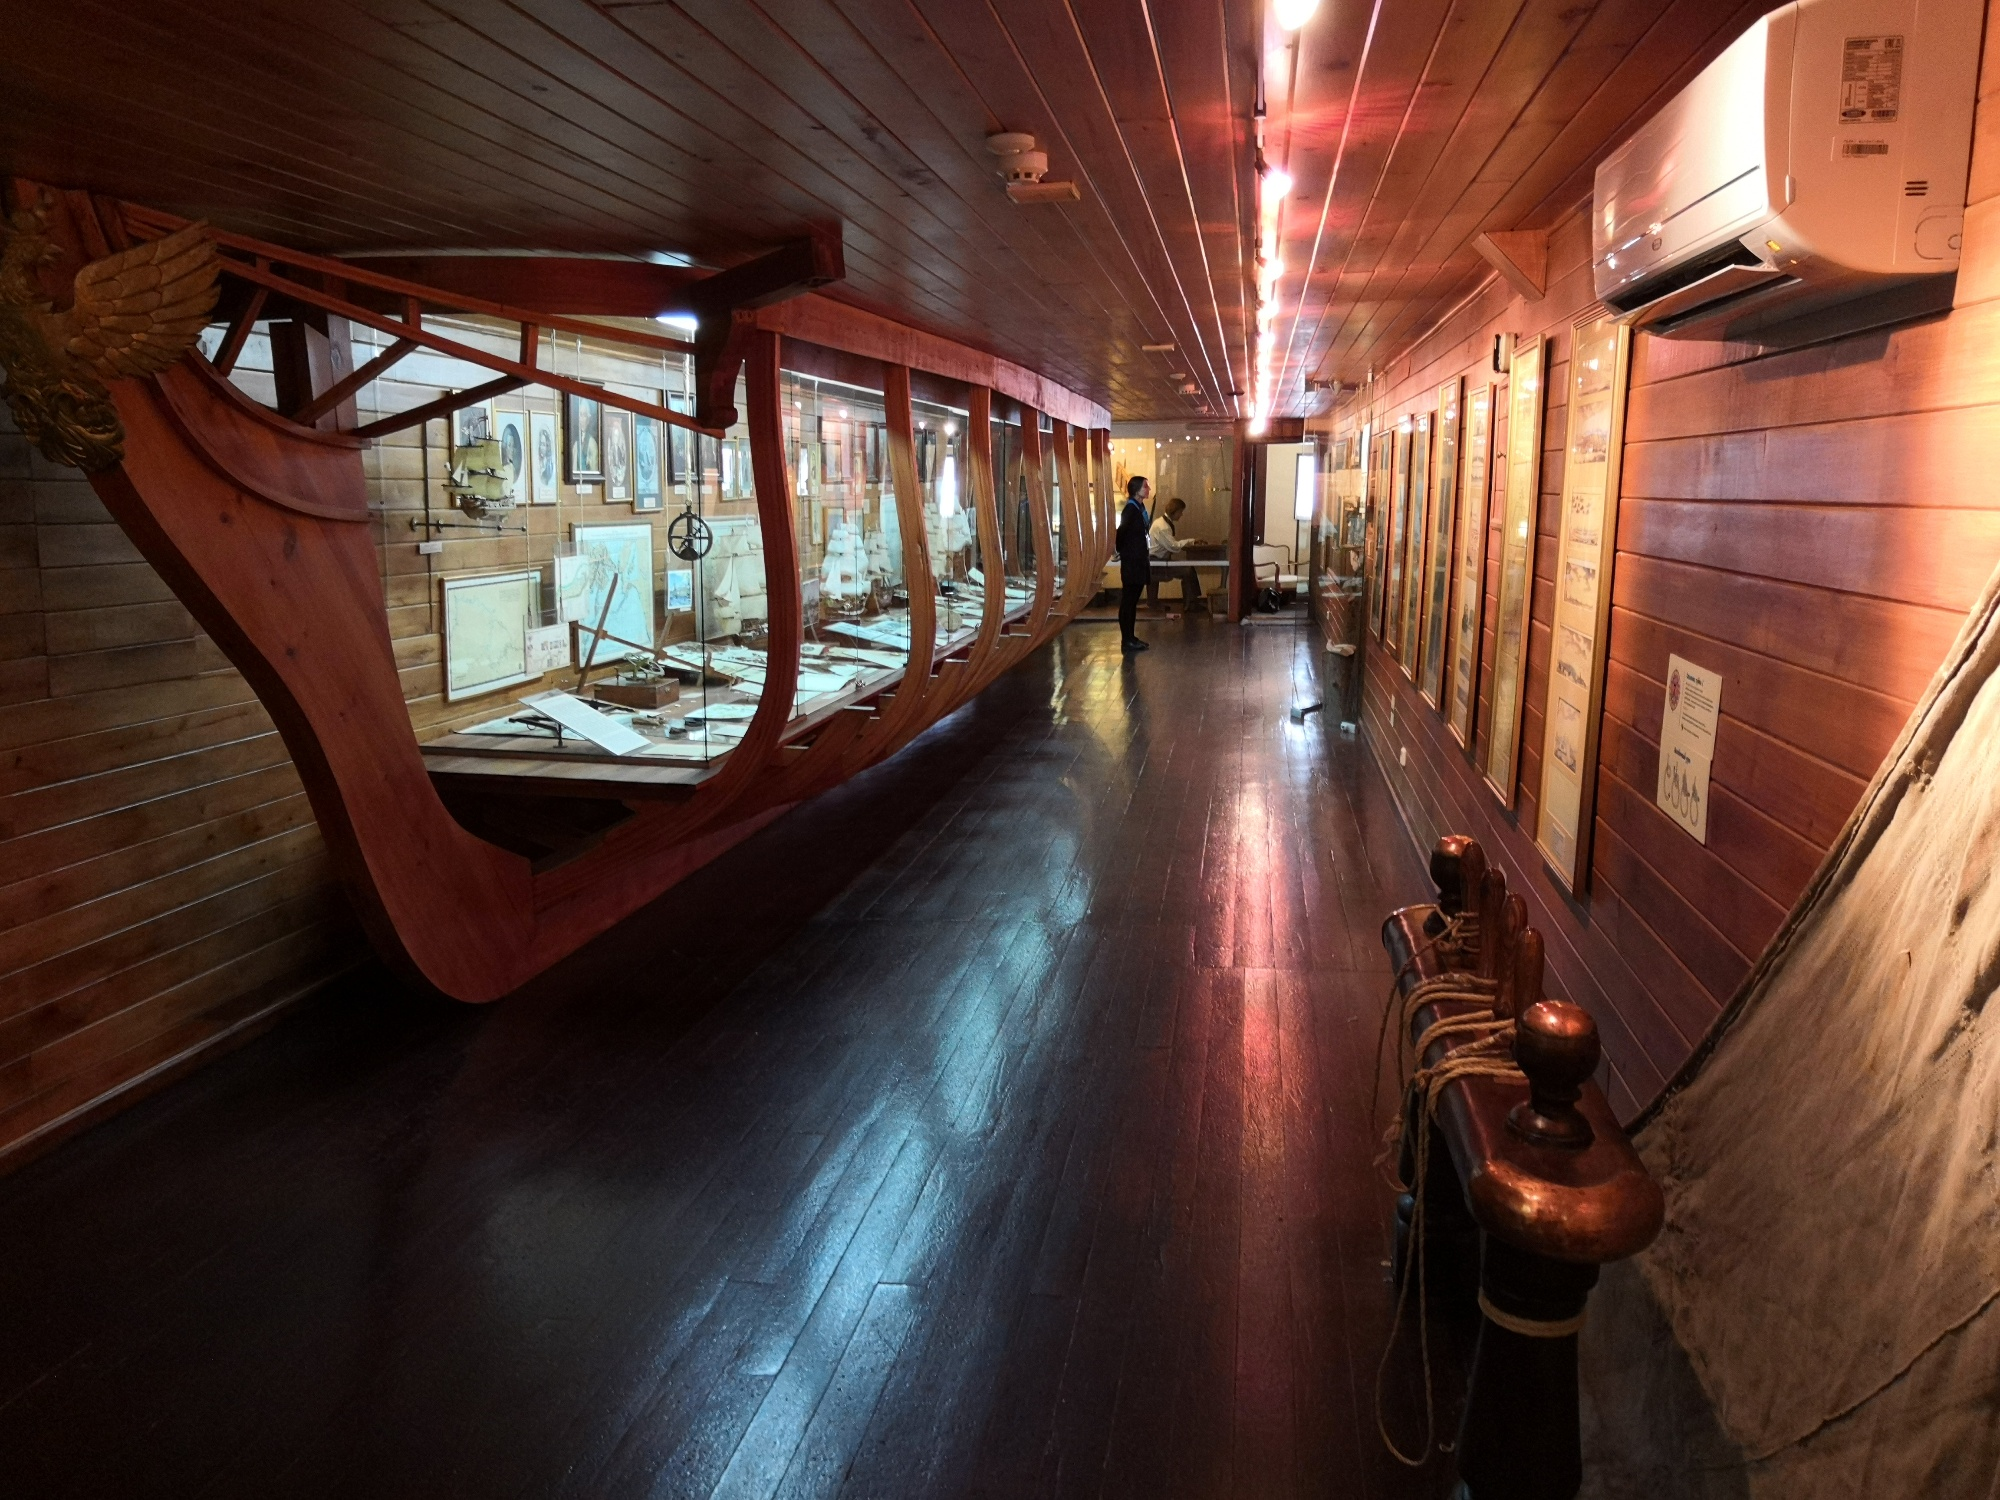What emotions do you think this scene evokes? The scene in this image evokes a sense of awe and reverence for the history of maritime exploration. The dim lighting and the thoughtful arrangement of artifacts create a contemplative atmosphere, encouraging visitors to reflect on the challenges and triumphs of early explorers. There's a blend of curiosity and nostalgia, as one imagines the adventures and hardships faced by sailors of the past. Additionally, the meticulous preservation and presentation of these historical objects foster a deep appreciation for the heritage and the advancements in navigation that shaped our modern world. 